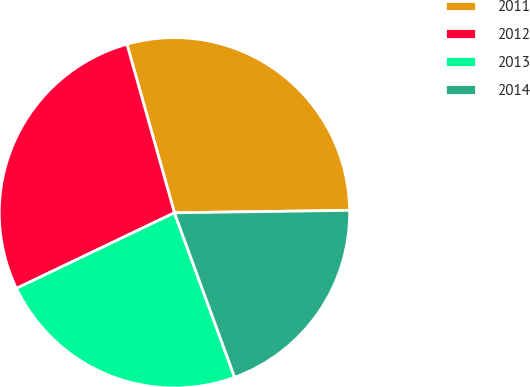<chart> <loc_0><loc_0><loc_500><loc_500><pie_chart><fcel>2011<fcel>2012<fcel>2013<fcel>2014<nl><fcel>29.15%<fcel>27.73%<fcel>23.48%<fcel>19.64%<nl></chart> 